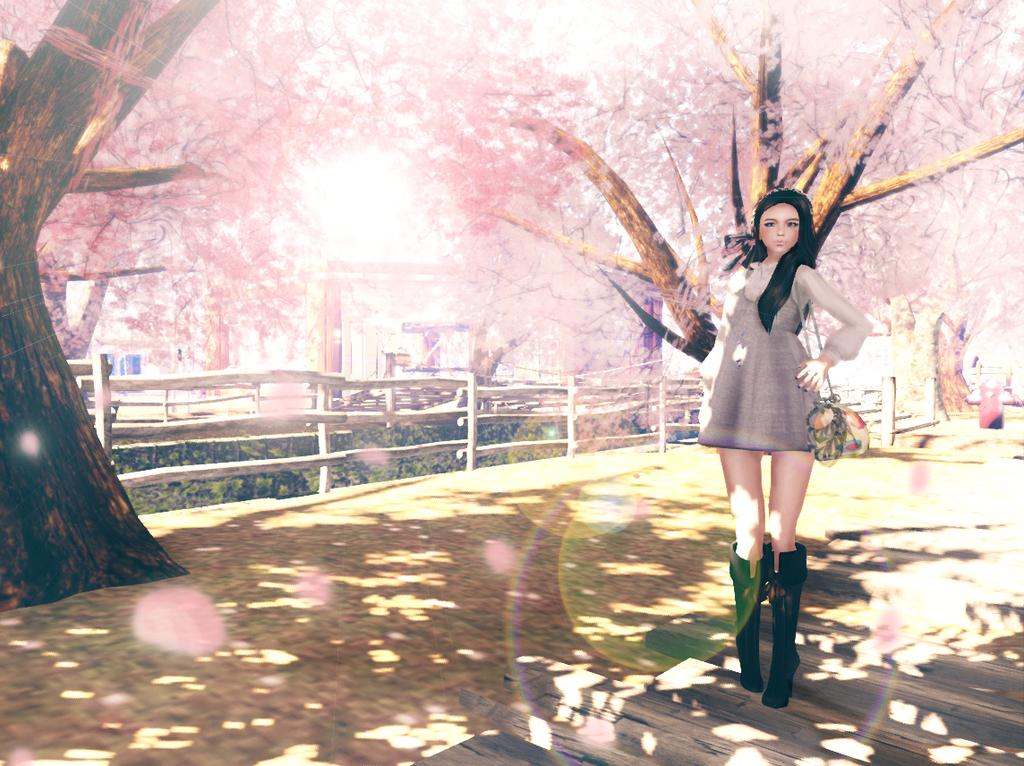What is the main subject in the image? There is a woman standing in the image. What can be seen in the background of the image? There is a fence and trees in the background of the image. Where is the hen sitting on the cushion in the image? There is no hen or cushion present in the image. 